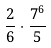Convert formula to latex. <formula><loc_0><loc_0><loc_500><loc_500>\frac { 2 } { 6 } \cdot \frac { 7 ^ { 6 } } { 5 }</formula> 